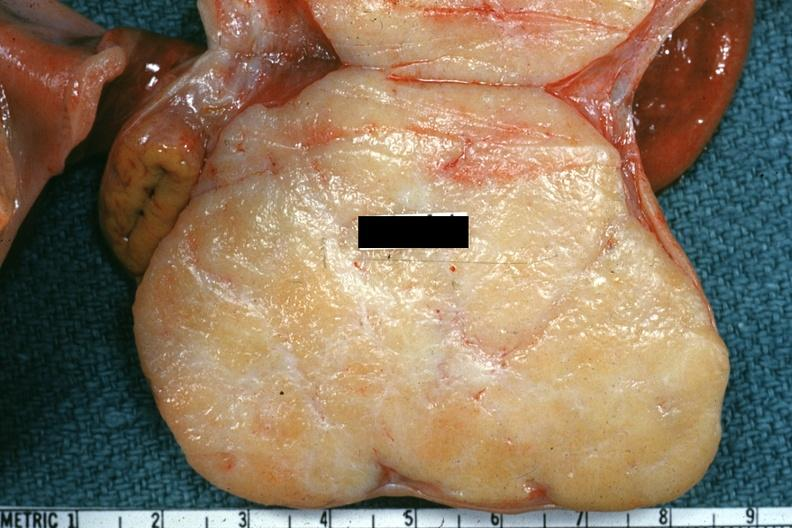what does this image show?
Answer the question using a single word or phrase. Excellent example of brenner tumor 